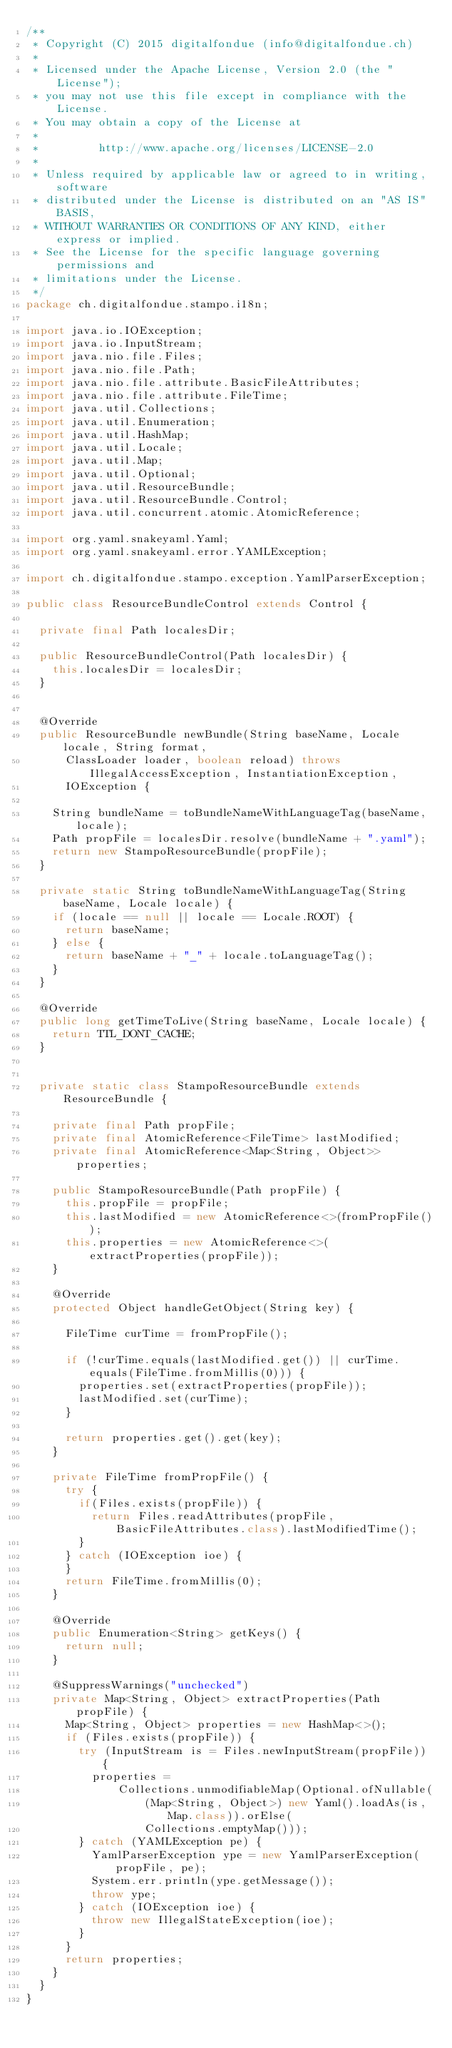Convert code to text. <code><loc_0><loc_0><loc_500><loc_500><_Java_>/**
 * Copyright (C) 2015 digitalfondue (info@digitalfondue.ch)
 *
 * Licensed under the Apache License, Version 2.0 (the "License");
 * you may not use this file except in compliance with the License.
 * You may obtain a copy of the License at
 *
 *         http://www.apache.org/licenses/LICENSE-2.0
 *
 * Unless required by applicable law or agreed to in writing, software
 * distributed under the License is distributed on an "AS IS" BASIS,
 * WITHOUT WARRANTIES OR CONDITIONS OF ANY KIND, either express or implied.
 * See the License for the specific language governing permissions and
 * limitations under the License.
 */
package ch.digitalfondue.stampo.i18n;

import java.io.IOException;
import java.io.InputStream;
import java.nio.file.Files;
import java.nio.file.Path;
import java.nio.file.attribute.BasicFileAttributes;
import java.nio.file.attribute.FileTime;
import java.util.Collections;
import java.util.Enumeration;
import java.util.HashMap;
import java.util.Locale;
import java.util.Map;
import java.util.Optional;
import java.util.ResourceBundle;
import java.util.ResourceBundle.Control;
import java.util.concurrent.atomic.AtomicReference;

import org.yaml.snakeyaml.Yaml;
import org.yaml.snakeyaml.error.YAMLException;

import ch.digitalfondue.stampo.exception.YamlParserException;

public class ResourceBundleControl extends Control {

  private final Path localesDir;

  public ResourceBundleControl(Path localesDir) {
    this.localesDir = localesDir;
  }
  

  @Override
  public ResourceBundle newBundle(String baseName, Locale locale, String format,
      ClassLoader loader, boolean reload) throws IllegalAccessException, InstantiationException,
      IOException {

    String bundleName = toBundleNameWithLanguageTag(baseName, locale);
    Path propFile = localesDir.resolve(bundleName + ".yaml");
    return new StampoResourceBundle(propFile);
  }
  
  private static String toBundleNameWithLanguageTag(String baseName, Locale locale) {
    if (locale == null || locale == Locale.ROOT) {
      return baseName;
    } else {
      return baseName + "_" + locale.toLanguageTag();
    }
  }
  
  @Override
  public long getTimeToLive(String baseName, Locale locale) {
    return TTL_DONT_CACHE;
  }


  private static class StampoResourceBundle extends ResourceBundle {

    private final Path propFile;
    private final AtomicReference<FileTime> lastModified;
    private final AtomicReference<Map<String, Object>> properties;

    public StampoResourceBundle(Path propFile) {
      this.propFile = propFile;
      this.lastModified = new AtomicReference<>(fromPropFile());
      this.properties = new AtomicReference<>(extractProperties(propFile));
    }

    @Override
    protected Object handleGetObject(String key) {
      
      FileTime curTime = fromPropFile();
      
      if (!curTime.equals(lastModified.get()) || curTime.equals(FileTime.fromMillis(0))) {
        properties.set(extractProperties(propFile));
        lastModified.set(curTime);
      }
      
      return properties.get().get(key);
    }
    
    private FileTime fromPropFile() {
      try {
        if(Files.exists(propFile)) {
          return Files.readAttributes(propFile, BasicFileAttributes.class).lastModifiedTime();
        }
      } catch (IOException ioe) {
      }
      return FileTime.fromMillis(0);
    }

    @Override
    public Enumeration<String> getKeys() {
      return null;
    }

    @SuppressWarnings("unchecked")
    private Map<String, Object> extractProperties(Path propFile) {
      Map<String, Object> properties = new HashMap<>();
      if (Files.exists(propFile)) {
        try (InputStream is = Files.newInputStream(propFile)) {
          properties =
              Collections.unmodifiableMap(Optional.ofNullable(
                  (Map<String, Object>) new Yaml().loadAs(is, Map.class)).orElse(
                  Collections.emptyMap()));
        } catch (YAMLException pe) {
          YamlParserException ype = new YamlParserException(propFile, pe);
          System.err.println(ype.getMessage());
          throw ype;
        } catch (IOException ioe) {
          throw new IllegalStateException(ioe);
        }
      }
      return properties;
    }
  }
}
</code> 